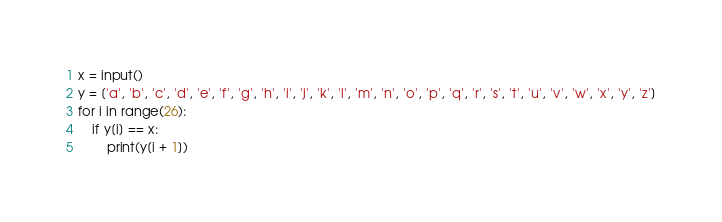<code> <loc_0><loc_0><loc_500><loc_500><_Python_>x = input()
y = ['a', 'b', 'c', 'd', 'e', 'f', 'g', 'h', 'i', 'j', 'k', 'l', 'm', 'n', 'o', 'p', 'q', 'r', 's', 't', 'u', 'v', 'w', 'x', 'y', 'z']
for i in range(26):
    if y[i] == x:
        print(y[i + 1])</code> 